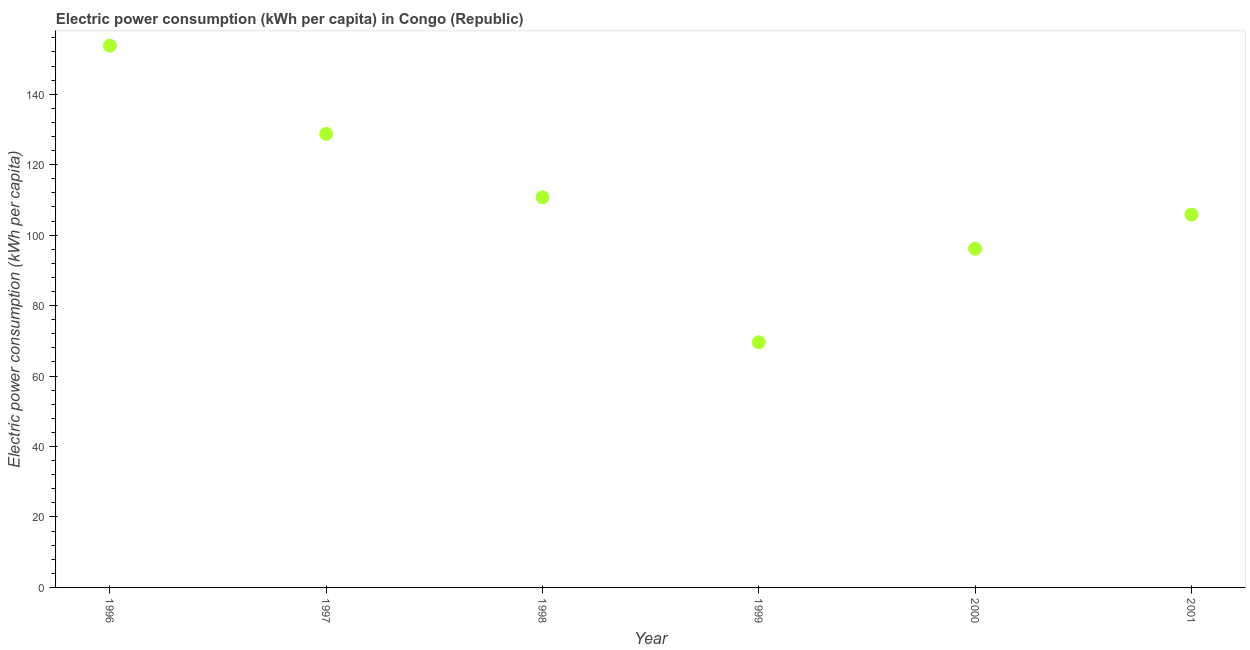What is the electric power consumption in 1999?
Ensure brevity in your answer.  69.59. Across all years, what is the maximum electric power consumption?
Keep it short and to the point. 153.8. Across all years, what is the minimum electric power consumption?
Keep it short and to the point. 69.59. In which year was the electric power consumption maximum?
Offer a terse response. 1996. What is the sum of the electric power consumption?
Your answer should be very brief. 664.89. What is the difference between the electric power consumption in 1997 and 2000?
Offer a terse response. 32.59. What is the average electric power consumption per year?
Provide a short and direct response. 110.81. What is the median electric power consumption?
Ensure brevity in your answer.  108.29. In how many years, is the electric power consumption greater than 104 kWh per capita?
Provide a succinct answer. 4. What is the ratio of the electric power consumption in 1997 to that in 1998?
Ensure brevity in your answer.  1.16. Is the electric power consumption in 1997 less than that in 2000?
Offer a terse response. No. Is the difference between the electric power consumption in 1998 and 1999 greater than the difference between any two years?
Make the answer very short. No. What is the difference between the highest and the second highest electric power consumption?
Provide a short and direct response. 25.04. Is the sum of the electric power consumption in 1996 and 2000 greater than the maximum electric power consumption across all years?
Offer a terse response. Yes. What is the difference between the highest and the lowest electric power consumption?
Ensure brevity in your answer.  84.2. How many dotlines are there?
Provide a short and direct response. 1. What is the difference between two consecutive major ticks on the Y-axis?
Provide a short and direct response. 20. Does the graph contain grids?
Ensure brevity in your answer.  No. What is the title of the graph?
Your answer should be compact. Electric power consumption (kWh per capita) in Congo (Republic). What is the label or title of the X-axis?
Make the answer very short. Year. What is the label or title of the Y-axis?
Keep it short and to the point. Electric power consumption (kWh per capita). What is the Electric power consumption (kWh per capita) in 1996?
Provide a succinct answer. 153.8. What is the Electric power consumption (kWh per capita) in 1997?
Keep it short and to the point. 128.76. What is the Electric power consumption (kWh per capita) in 1998?
Offer a very short reply. 110.73. What is the Electric power consumption (kWh per capita) in 1999?
Provide a succinct answer. 69.59. What is the Electric power consumption (kWh per capita) in 2000?
Offer a very short reply. 96.16. What is the Electric power consumption (kWh per capita) in 2001?
Keep it short and to the point. 105.85. What is the difference between the Electric power consumption (kWh per capita) in 1996 and 1997?
Provide a short and direct response. 25.04. What is the difference between the Electric power consumption (kWh per capita) in 1996 and 1998?
Offer a terse response. 43.06. What is the difference between the Electric power consumption (kWh per capita) in 1996 and 1999?
Offer a very short reply. 84.2. What is the difference between the Electric power consumption (kWh per capita) in 1996 and 2000?
Your answer should be very brief. 57.63. What is the difference between the Electric power consumption (kWh per capita) in 1996 and 2001?
Provide a succinct answer. 47.95. What is the difference between the Electric power consumption (kWh per capita) in 1997 and 1998?
Provide a short and direct response. 18.02. What is the difference between the Electric power consumption (kWh per capita) in 1997 and 1999?
Offer a terse response. 59.16. What is the difference between the Electric power consumption (kWh per capita) in 1997 and 2000?
Your response must be concise. 32.59. What is the difference between the Electric power consumption (kWh per capita) in 1997 and 2001?
Keep it short and to the point. 22.91. What is the difference between the Electric power consumption (kWh per capita) in 1998 and 1999?
Your answer should be compact. 41.14. What is the difference between the Electric power consumption (kWh per capita) in 1998 and 2000?
Provide a succinct answer. 14.57. What is the difference between the Electric power consumption (kWh per capita) in 1998 and 2001?
Keep it short and to the point. 4.89. What is the difference between the Electric power consumption (kWh per capita) in 1999 and 2000?
Your response must be concise. -26.57. What is the difference between the Electric power consumption (kWh per capita) in 1999 and 2001?
Your response must be concise. -36.25. What is the difference between the Electric power consumption (kWh per capita) in 2000 and 2001?
Your answer should be compact. -9.68. What is the ratio of the Electric power consumption (kWh per capita) in 1996 to that in 1997?
Keep it short and to the point. 1.19. What is the ratio of the Electric power consumption (kWh per capita) in 1996 to that in 1998?
Give a very brief answer. 1.39. What is the ratio of the Electric power consumption (kWh per capita) in 1996 to that in 1999?
Offer a terse response. 2.21. What is the ratio of the Electric power consumption (kWh per capita) in 1996 to that in 2000?
Provide a short and direct response. 1.6. What is the ratio of the Electric power consumption (kWh per capita) in 1996 to that in 2001?
Offer a terse response. 1.45. What is the ratio of the Electric power consumption (kWh per capita) in 1997 to that in 1998?
Offer a terse response. 1.16. What is the ratio of the Electric power consumption (kWh per capita) in 1997 to that in 1999?
Offer a terse response. 1.85. What is the ratio of the Electric power consumption (kWh per capita) in 1997 to that in 2000?
Provide a succinct answer. 1.34. What is the ratio of the Electric power consumption (kWh per capita) in 1997 to that in 2001?
Your answer should be compact. 1.22. What is the ratio of the Electric power consumption (kWh per capita) in 1998 to that in 1999?
Offer a very short reply. 1.59. What is the ratio of the Electric power consumption (kWh per capita) in 1998 to that in 2000?
Your answer should be very brief. 1.15. What is the ratio of the Electric power consumption (kWh per capita) in 1998 to that in 2001?
Provide a short and direct response. 1.05. What is the ratio of the Electric power consumption (kWh per capita) in 1999 to that in 2000?
Your response must be concise. 0.72. What is the ratio of the Electric power consumption (kWh per capita) in 1999 to that in 2001?
Make the answer very short. 0.66. What is the ratio of the Electric power consumption (kWh per capita) in 2000 to that in 2001?
Provide a short and direct response. 0.91. 